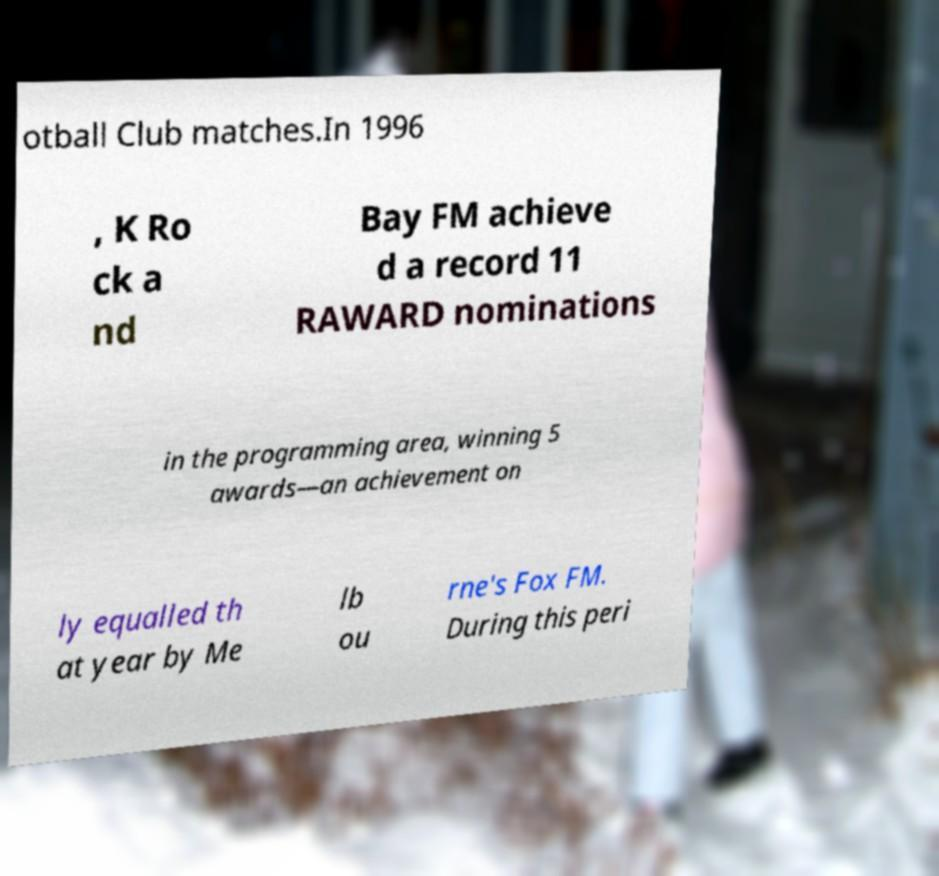Please read and relay the text visible in this image. What does it say? otball Club matches.In 1996 , K Ro ck a nd Bay FM achieve d a record 11 RAWARD nominations in the programming area, winning 5 awards—an achievement on ly equalled th at year by Me lb ou rne's Fox FM. During this peri 